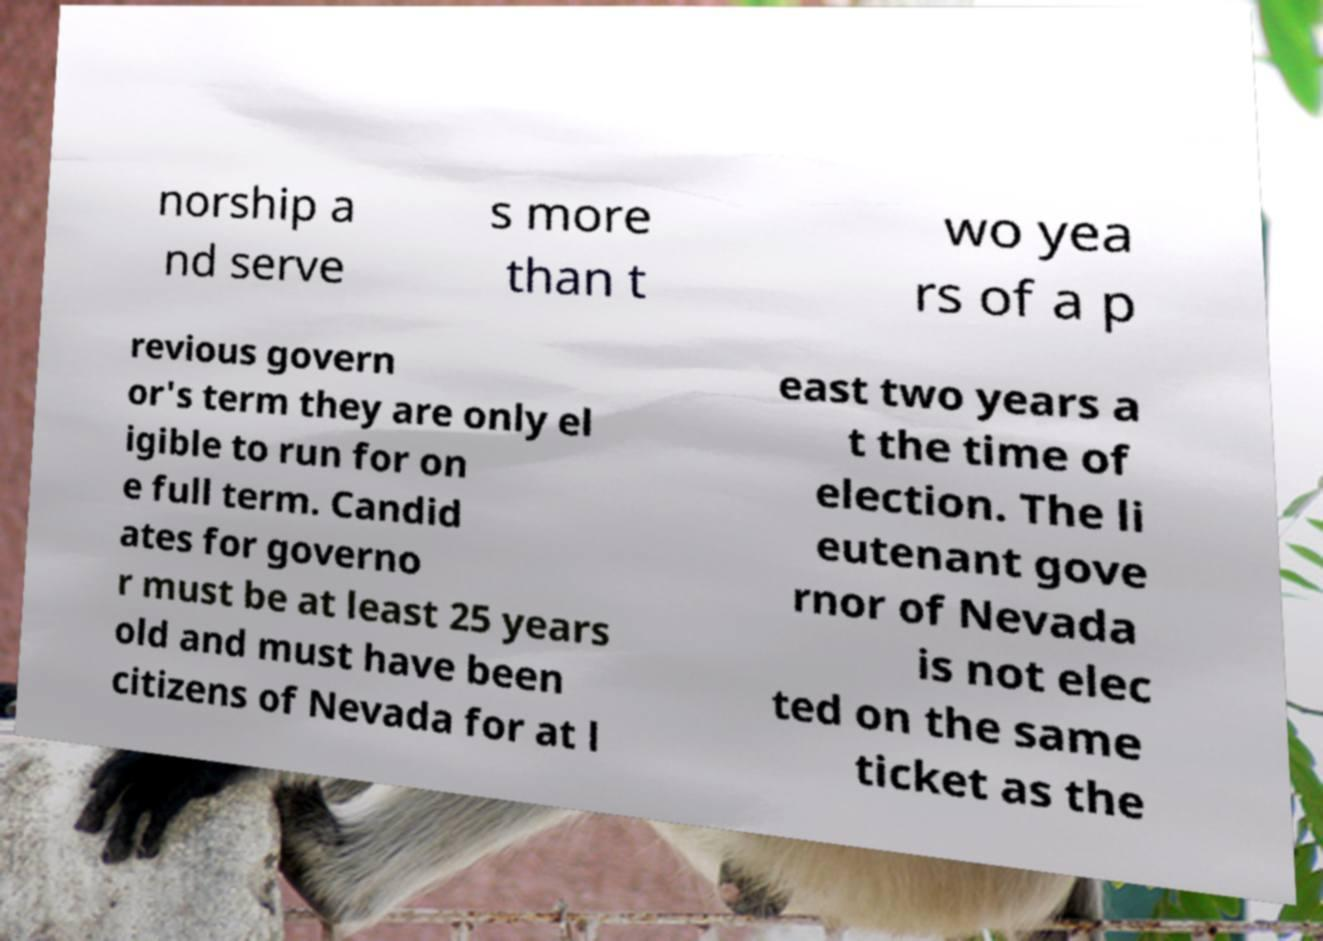Can you read and provide the text displayed in the image?This photo seems to have some interesting text. Can you extract and type it out for me? norship a nd serve s more than t wo yea rs of a p revious govern or's term they are only el igible to run for on e full term. Candid ates for governo r must be at least 25 years old and must have been citizens of Nevada for at l east two years a t the time of election. The li eutenant gove rnor of Nevada is not elec ted on the same ticket as the 